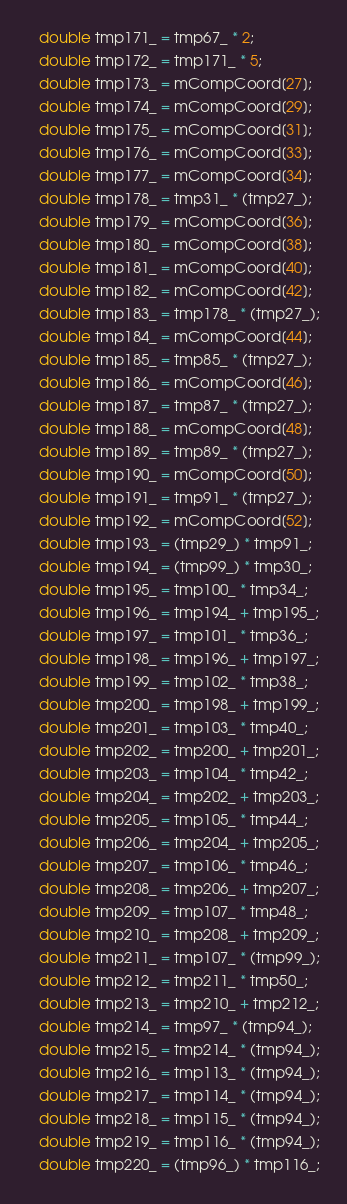<code> <loc_0><loc_0><loc_500><loc_500><_C++_>   double tmp171_ = tmp67_ * 2;
   double tmp172_ = tmp171_ * 5;
   double tmp173_ = mCompCoord[27];
   double tmp174_ = mCompCoord[29];
   double tmp175_ = mCompCoord[31];
   double tmp176_ = mCompCoord[33];
   double tmp177_ = mCompCoord[34];
   double tmp178_ = tmp31_ * (tmp27_);
   double tmp179_ = mCompCoord[36];
   double tmp180_ = mCompCoord[38];
   double tmp181_ = mCompCoord[40];
   double tmp182_ = mCompCoord[42];
   double tmp183_ = tmp178_ * (tmp27_);
   double tmp184_ = mCompCoord[44];
   double tmp185_ = tmp85_ * (tmp27_);
   double tmp186_ = mCompCoord[46];
   double tmp187_ = tmp87_ * (tmp27_);
   double tmp188_ = mCompCoord[48];
   double tmp189_ = tmp89_ * (tmp27_);
   double tmp190_ = mCompCoord[50];
   double tmp191_ = tmp91_ * (tmp27_);
   double tmp192_ = mCompCoord[52];
   double tmp193_ = (tmp29_) * tmp91_;
   double tmp194_ = (tmp99_) * tmp30_;
   double tmp195_ = tmp100_ * tmp34_;
   double tmp196_ = tmp194_ + tmp195_;
   double tmp197_ = tmp101_ * tmp36_;
   double tmp198_ = tmp196_ + tmp197_;
   double tmp199_ = tmp102_ * tmp38_;
   double tmp200_ = tmp198_ + tmp199_;
   double tmp201_ = tmp103_ * tmp40_;
   double tmp202_ = tmp200_ + tmp201_;
   double tmp203_ = tmp104_ * tmp42_;
   double tmp204_ = tmp202_ + tmp203_;
   double tmp205_ = tmp105_ * tmp44_;
   double tmp206_ = tmp204_ + tmp205_;
   double tmp207_ = tmp106_ * tmp46_;
   double tmp208_ = tmp206_ + tmp207_;
   double tmp209_ = tmp107_ * tmp48_;
   double tmp210_ = tmp208_ + tmp209_;
   double tmp211_ = tmp107_ * (tmp99_);
   double tmp212_ = tmp211_ * tmp50_;
   double tmp213_ = tmp210_ + tmp212_;
   double tmp214_ = tmp97_ * (tmp94_);
   double tmp215_ = tmp214_ * (tmp94_);
   double tmp216_ = tmp113_ * (tmp94_);
   double tmp217_ = tmp114_ * (tmp94_);
   double tmp218_ = tmp115_ * (tmp94_);
   double tmp219_ = tmp116_ * (tmp94_);
   double tmp220_ = (tmp96_) * tmp116_;
</code> 